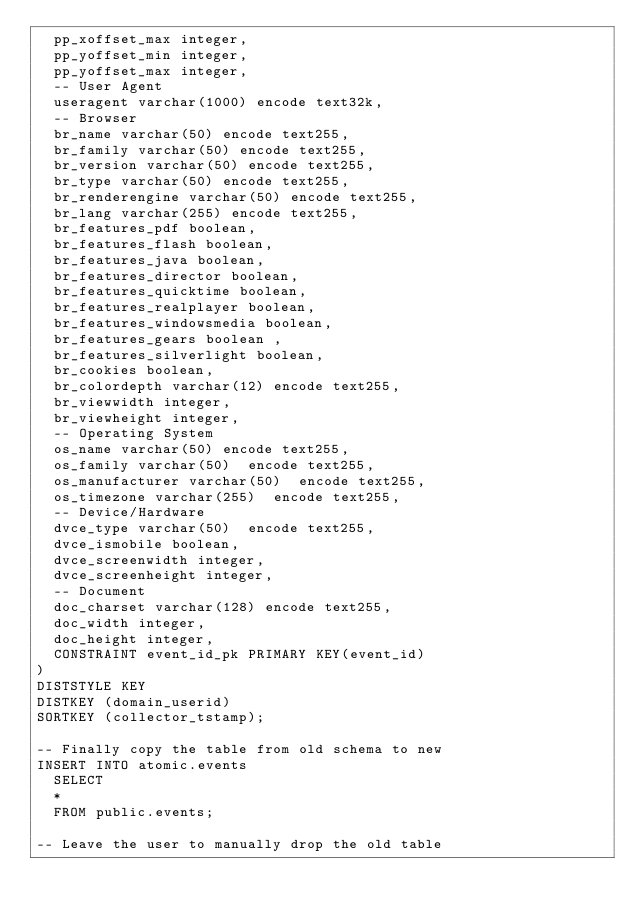Convert code to text. <code><loc_0><loc_0><loc_500><loc_500><_SQL_>	pp_xoffset_max integer,
	pp_yoffset_min integer,
	pp_yoffset_max integer,
	-- User Agent
	useragent varchar(1000) encode text32k,
	-- Browser
	br_name varchar(50) encode text255,
	br_family varchar(50) encode text255,
	br_version varchar(50) encode text255,
	br_type varchar(50) encode text255,
	br_renderengine varchar(50) encode text255,
	br_lang varchar(255) encode text255,
	br_features_pdf boolean,
	br_features_flash boolean,
	br_features_java boolean,
	br_features_director boolean,
	br_features_quicktime boolean,
	br_features_realplayer boolean,
	br_features_windowsmedia boolean,
	br_features_gears boolean ,
	br_features_silverlight boolean,
	br_cookies boolean,
	br_colordepth varchar(12) encode text255,
	br_viewwidth integer,
	br_viewheight integer,
	-- Operating System
	os_name varchar(50) encode text255,
	os_family varchar(50)  encode text255,
	os_manufacturer varchar(50)  encode text255,
	os_timezone varchar(255)  encode text255,
	-- Device/Hardware
	dvce_type varchar(50)  encode text255,
	dvce_ismobile boolean,
	dvce_screenwidth integer,
	dvce_screenheight integer,
	-- Document
	doc_charset varchar(128) encode text255,
	doc_width integer,
	doc_height integer,
	CONSTRAINT event_id_pk PRIMARY KEY(event_id)
)
DISTSTYLE KEY
DISTKEY (domain_userid)
SORTKEY (collector_tstamp);

-- Finally copy the table from old schema to new
INSERT INTO atomic.events
	SELECT
	*
	FROM public.events;

-- Leave the user to manually drop the old table
</code> 